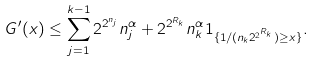<formula> <loc_0><loc_0><loc_500><loc_500>G ^ { \prime } ( x ) \leq \sum _ { j = 1 } ^ { k - 1 } 2 ^ { 2 ^ { n _ { j } } } n _ { j } ^ { \alpha } + 2 ^ { 2 ^ { R _ { k } } } n _ { k } ^ { \alpha } { 1 } _ { \{ 1 / ( n _ { k } 2 ^ { 2 ^ { R _ { k } } } ) \geq x \} } .</formula> 